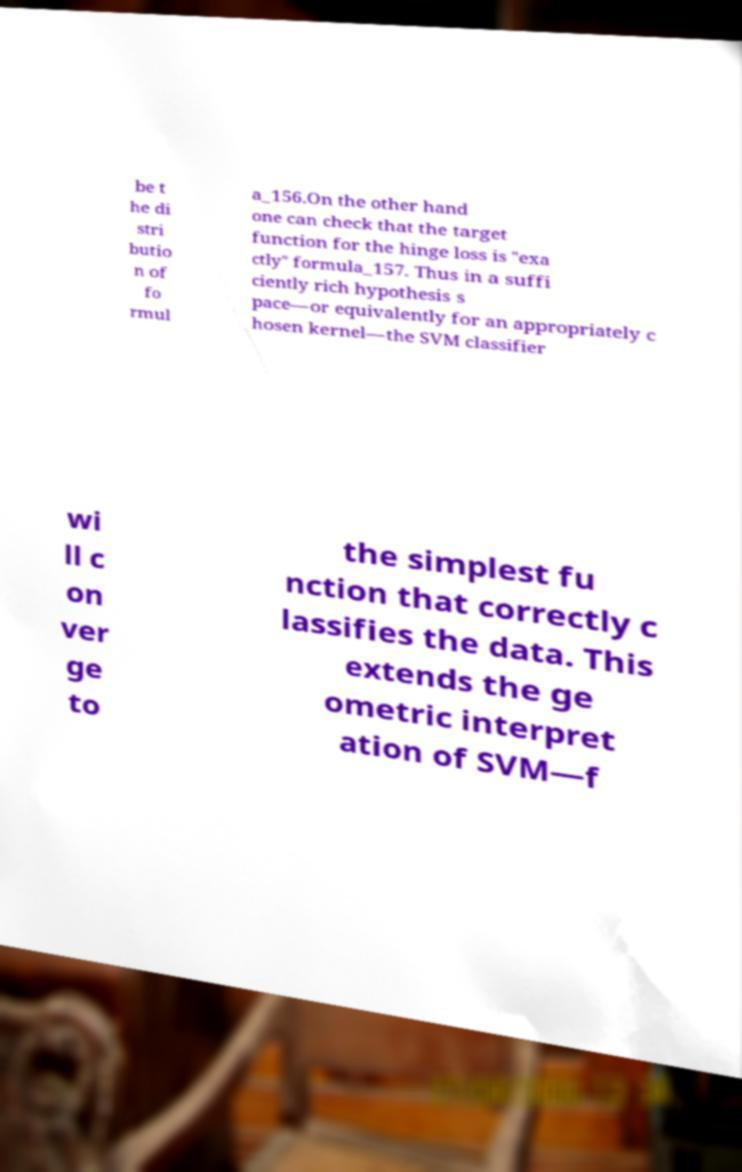What messages or text are displayed in this image? I need them in a readable, typed format. be t he di stri butio n of fo rmul a_156.On the other hand one can check that the target function for the hinge loss is "exa ctly" formula_157. Thus in a suffi ciently rich hypothesis s pace—or equivalently for an appropriately c hosen kernel—the SVM classifier wi ll c on ver ge to the simplest fu nction that correctly c lassifies the data. This extends the ge ometric interpret ation of SVM—f 